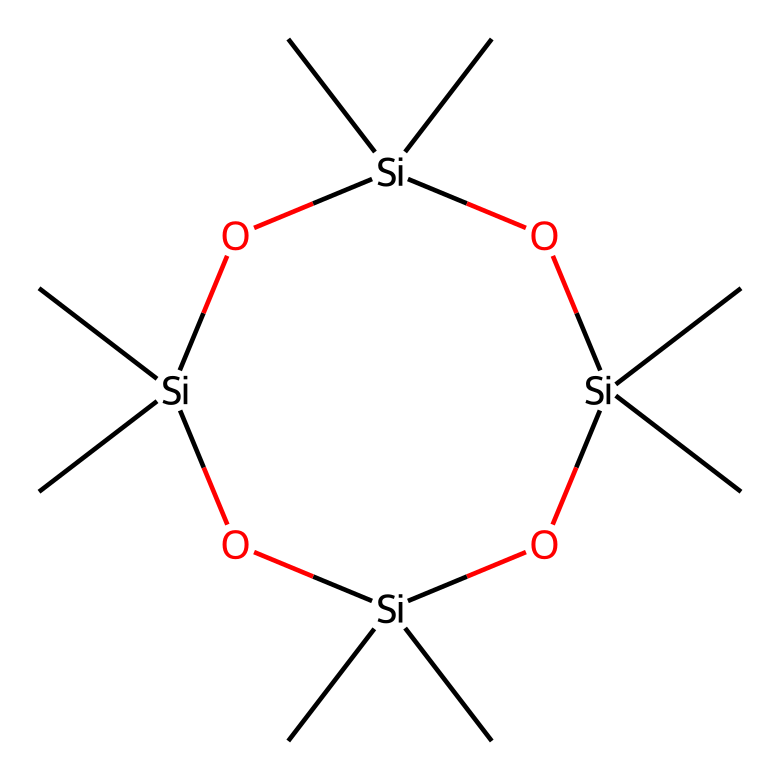What is the name of this chemical? The SMILES representation indicates a cyclic siloxane structure made up of silicon and oxygen atoms with methyl groups, which identifies it as octamethylcyclotetrasiloxane.
Answer: octamethylcyclotetrasiloxane How many silicon atoms are present in this structure? Analyzing the SMILES structure, there are four silicon atoms represented as 'Si', indicating the presence of four silicon atoms.
Answer: four What type of bonding is mainly present between the silicon and oxygen in this compound? The bonding between silicon and oxygen in siloxanes is typically through Si-O bonds, indicating siloxane bonding.
Answer: siloxane What is the overall structure type of this chemical? The structure shows a ring of siloxane units, confirming it is a cyclic siloxane or cyclotetrasiloxane.
Answer: cyclic siloxane What functional groups are found in this chemical? The presence of the -Si-O- repeating units classifies it as having siloxane functional groups.
Answer: siloxane How many methyl groups are present in the structure? Each of the four silicon atoms has two methyl groups attached, totaling eight methyl groups in the compound.
Answer: eight 